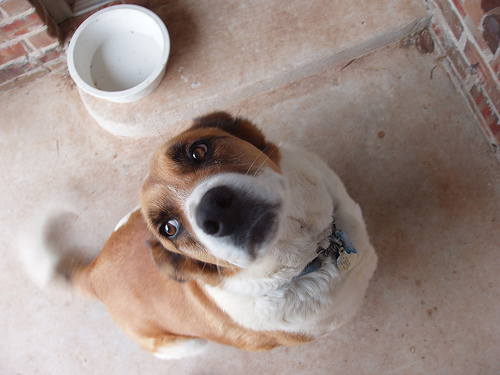<image>
Is there a dog under the water bowl? No. The dog is not positioned under the water bowl. The vertical relationship between these objects is different. Is there a bowl behind the dog? Yes. From this viewpoint, the bowl is positioned behind the dog, with the dog partially or fully occluding the bowl. 